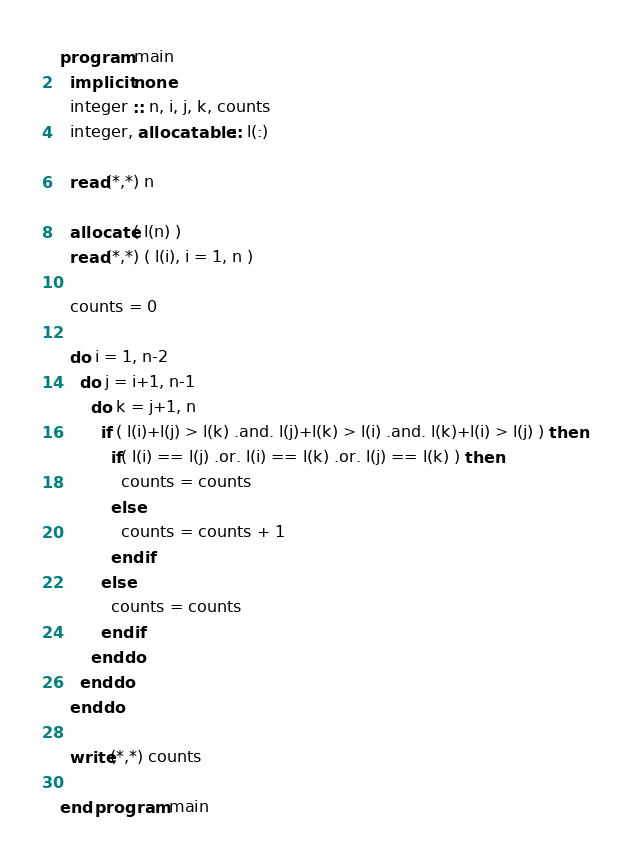Convert code to text. <code><loc_0><loc_0><loc_500><loc_500><_FORTRAN_>program main
  implicit none
  integer :: n, i, j, k, counts
  integer, allocatable :: l(:)
  
  read(*,*) n
  
  allocate( l(n) )
  read(*,*) ( l(i), i = 1, n )
  
  counts = 0
  
  do i = 1, n-2
    do j = i+1, n-1
      do k = j+1, n
        if ( l(i)+l(j) > l(k) .and. l(j)+l(k) > l(i) .and. l(k)+l(i) > l(j) ) then
          if( l(i) == l(j) .or. l(i) == l(k) .or. l(j) == l(k) ) then
            counts = counts
          else
            counts = counts + 1
          endif
        else
          counts = counts
        endif
      enddo
    enddo
  enddo
  
  write(*,*) counts
  
end program main</code> 